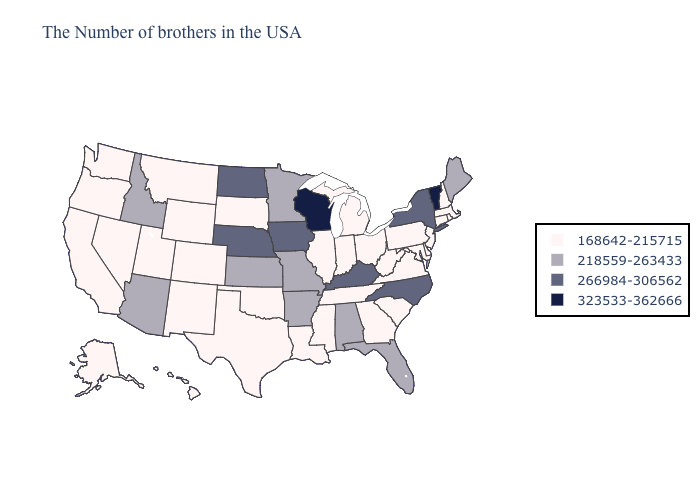Which states have the highest value in the USA?
Keep it brief. Vermont, Wisconsin. Does Kentucky have the same value as North Dakota?
Quick response, please. Yes. Among the states that border Kansas , does Colorado have the highest value?
Answer briefly. No. What is the lowest value in states that border Arizona?
Concise answer only. 168642-215715. Name the states that have a value in the range 266984-306562?
Concise answer only. New York, North Carolina, Kentucky, Iowa, Nebraska, North Dakota. What is the value of Iowa?
Concise answer only. 266984-306562. Name the states that have a value in the range 266984-306562?
Be succinct. New York, North Carolina, Kentucky, Iowa, Nebraska, North Dakota. What is the value of Iowa?
Concise answer only. 266984-306562. Does New Hampshire have the lowest value in the Northeast?
Give a very brief answer. Yes. What is the highest value in states that border Virginia?
Concise answer only. 266984-306562. Among the states that border Minnesota , which have the highest value?
Be succinct. Wisconsin. Which states hav the highest value in the South?
Answer briefly. North Carolina, Kentucky. What is the highest value in states that border Nevada?
Give a very brief answer. 218559-263433. Among the states that border Oklahoma , does Arkansas have the highest value?
Short answer required. Yes. 